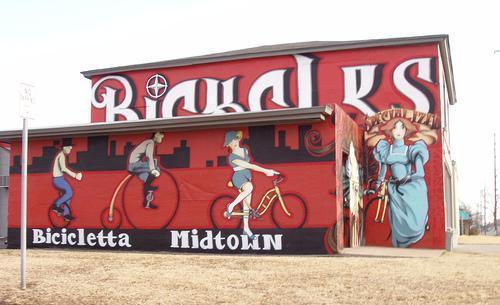How many people are riding unicycles?
Give a very brief answer. 1. 